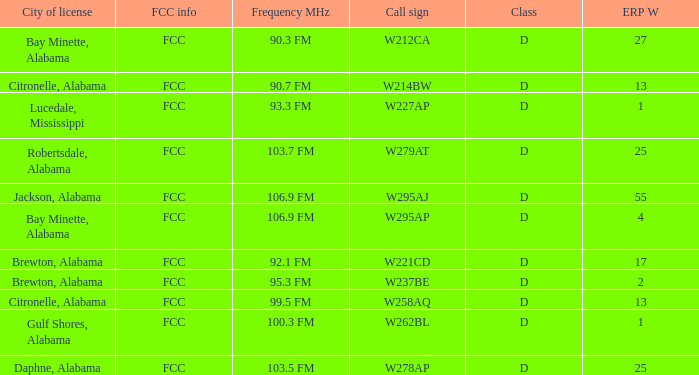Name the call sign for ERP W of 4 W295AP. 